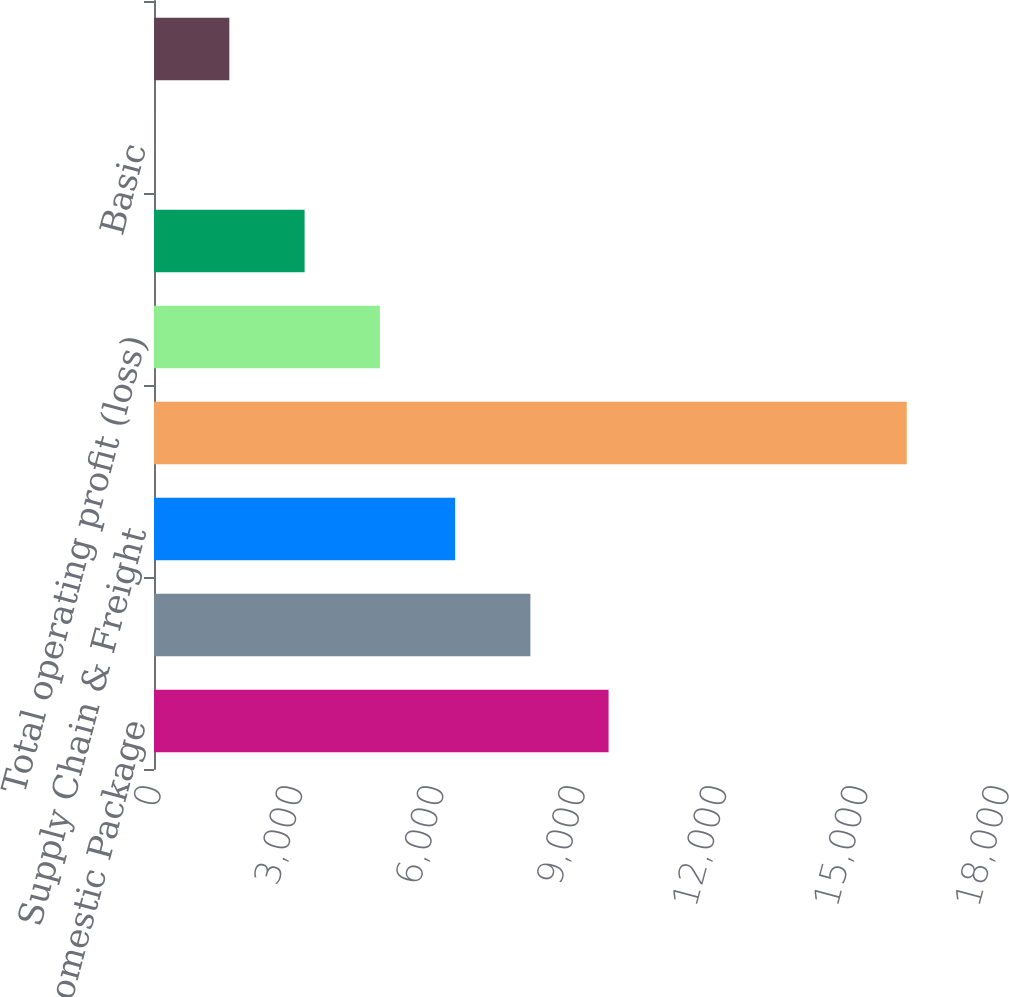<chart> <loc_0><loc_0><loc_500><loc_500><bar_chart><fcel>US Domestic Package<fcel>International Package<fcel>Supply Chain & Freight<fcel>Total revenue<fcel>Total operating profit (loss)<fcel>Net Income (Loss)<fcel>Basic<fcel>Diluted<nl><fcel>9649<fcel>7989.72<fcel>6392.06<fcel>15978<fcel>4794.41<fcel>3196.76<fcel>1.45<fcel>1599.11<nl></chart> 